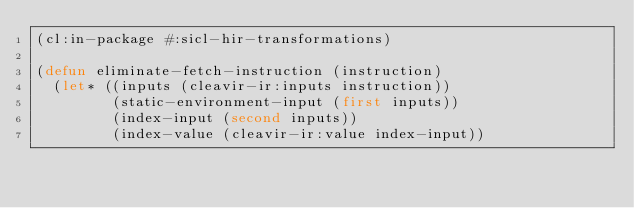Convert code to text. <code><loc_0><loc_0><loc_500><loc_500><_Lisp_>(cl:in-package #:sicl-hir-transformations)

(defun eliminate-fetch-instruction (instruction)
  (let* ((inputs (cleavir-ir:inputs instruction))
         (static-environment-input (first inputs))
         (index-input (second inputs))
         (index-value (cleavir-ir:value index-input))</code> 